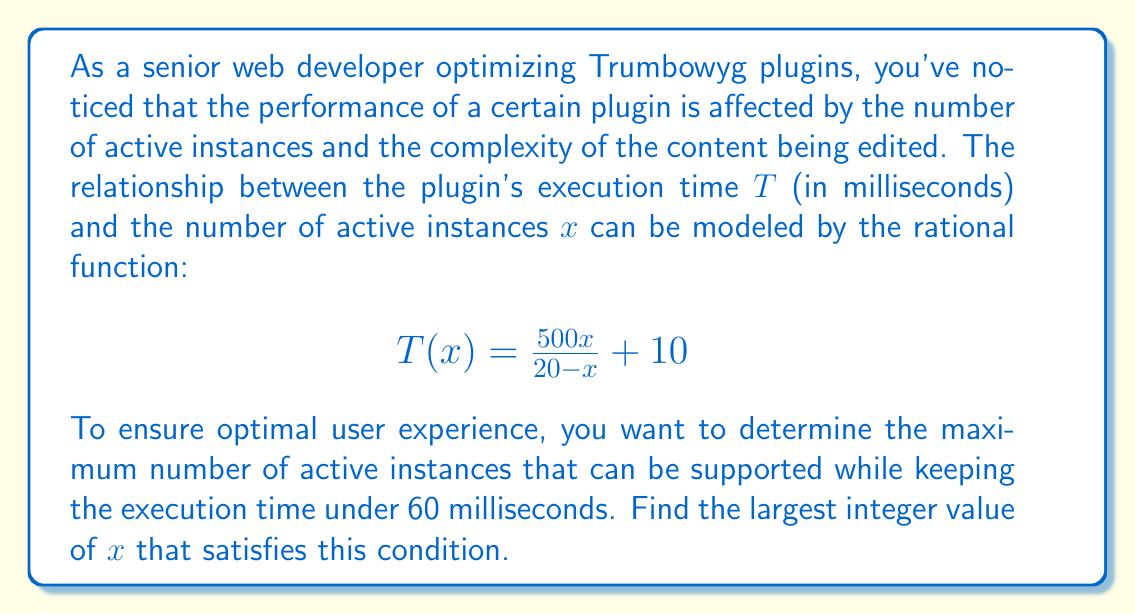Show me your answer to this math problem. Let's approach this step-by-step:

1) We need to solve the inequality:
   $$T(x) < 60$$

2) Substituting the given function:
   $$\frac{500x}{20 - x} + 10 < 60$$

3) Subtract 10 from both sides:
   $$\frac{500x}{20 - x} < 50$$

4) Multiply both sides by $(20 - x)$. Note that $20 - x > 0$ for this to be valid:
   $$500x < 50(20 - x)$$

5) Expand the right side:
   $$500x < 1000 - 50x$$

6) Add $50x$ to both sides:
   $$550x < 1000$$

7) Divide both sides by 550:
   $$x < \frac{1000}{550} \approx 1.8181$$

8) Since $x$ represents the number of instances, it must be a positive integer.
   The largest integer value of $x$ that satisfies this inequality is 1.

9) Let's verify:
   For $x = 1$: $T(1) = \frac{500(1)}{20 - 1} + 10 = \frac{500}{19} + 10 \approx 36.32$ ms
   For $x = 2$: $T(2) = \frac{500(2)}{20 - 2} + 10 = \frac{1000}{18} + 10 \approx 65.56$ ms

Therefore, the largest integer value of $x$ that keeps the execution time under 60 ms is 1.
Answer: 1 